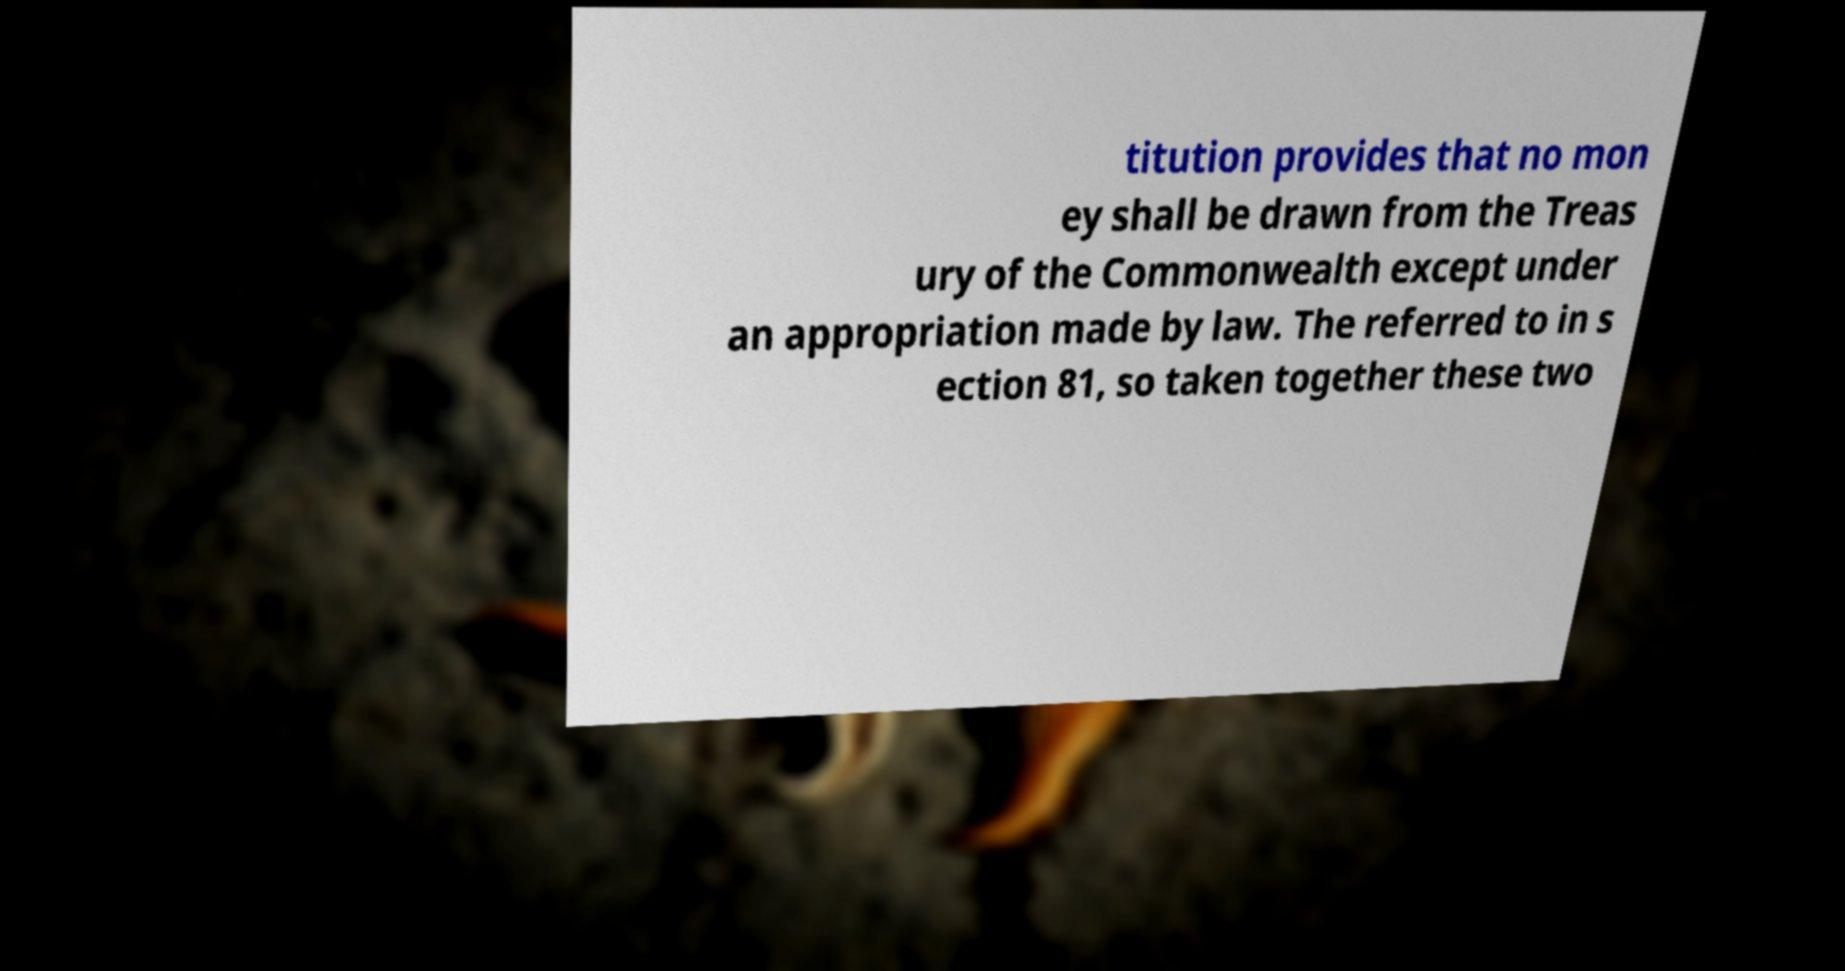Please read and relay the text visible in this image. What does it say? titution provides that no mon ey shall be drawn from the Treas ury of the Commonwealth except under an appropriation made by law. The referred to in s ection 81, so taken together these two 